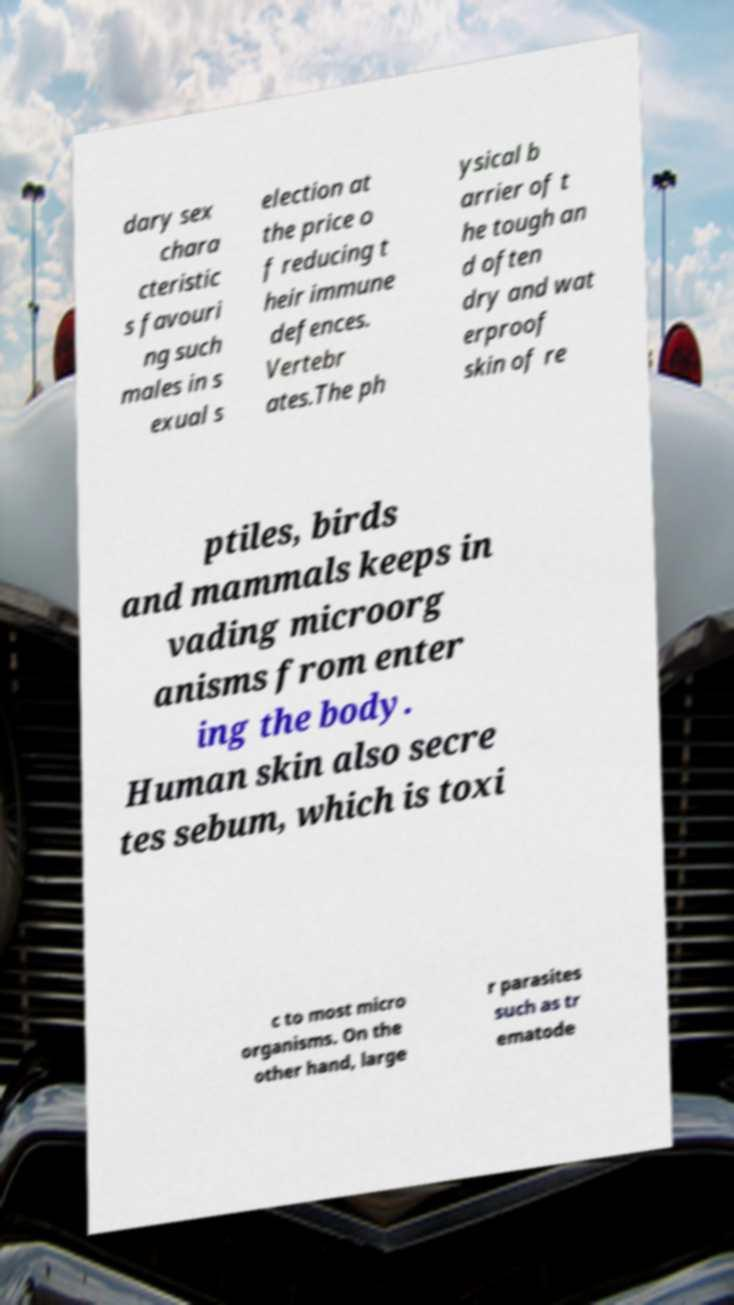For documentation purposes, I need the text within this image transcribed. Could you provide that? dary sex chara cteristic s favouri ng such males in s exual s election at the price o f reducing t heir immune defences. Vertebr ates.The ph ysical b arrier of t he tough an d often dry and wat erproof skin of re ptiles, birds and mammals keeps in vading microorg anisms from enter ing the body. Human skin also secre tes sebum, which is toxi c to most micro organisms. On the other hand, large r parasites such as tr ematode 